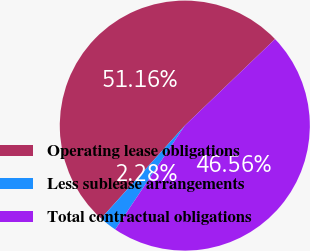Convert chart to OTSL. <chart><loc_0><loc_0><loc_500><loc_500><pie_chart><fcel>Operating lease obligations<fcel>Less sublease arrangements<fcel>Total contractual obligations<nl><fcel>51.16%<fcel>2.28%<fcel>46.56%<nl></chart> 